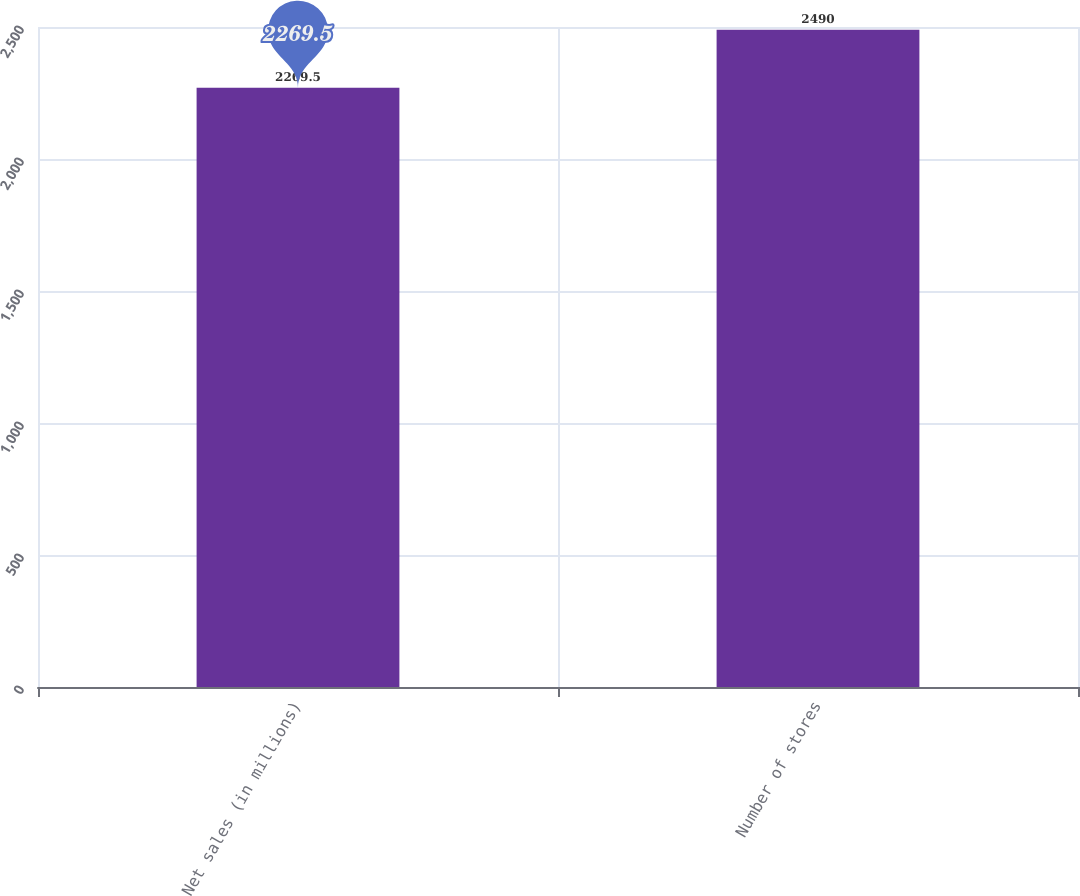Convert chart to OTSL. <chart><loc_0><loc_0><loc_500><loc_500><bar_chart><fcel>Net sales (in millions)<fcel>Number of stores<nl><fcel>2269.5<fcel>2490<nl></chart> 